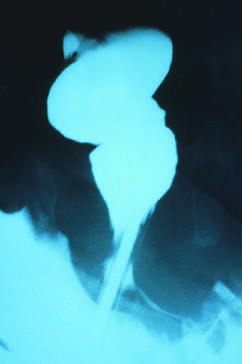where were ganglion cells absent?
Answer the question using a single word or phrase. In the rectum 